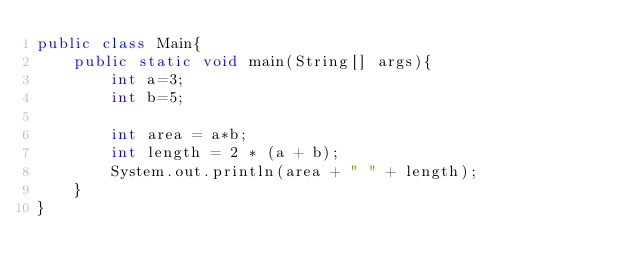Convert code to text. <code><loc_0><loc_0><loc_500><loc_500><_Java_>public class Main{
	public static void main(String[] args){
		int a=3;
		int b=5;

		int area = a*b;
		int length = 2 * (a + b);
		System.out.println(area + " " + length);
	}
}</code> 